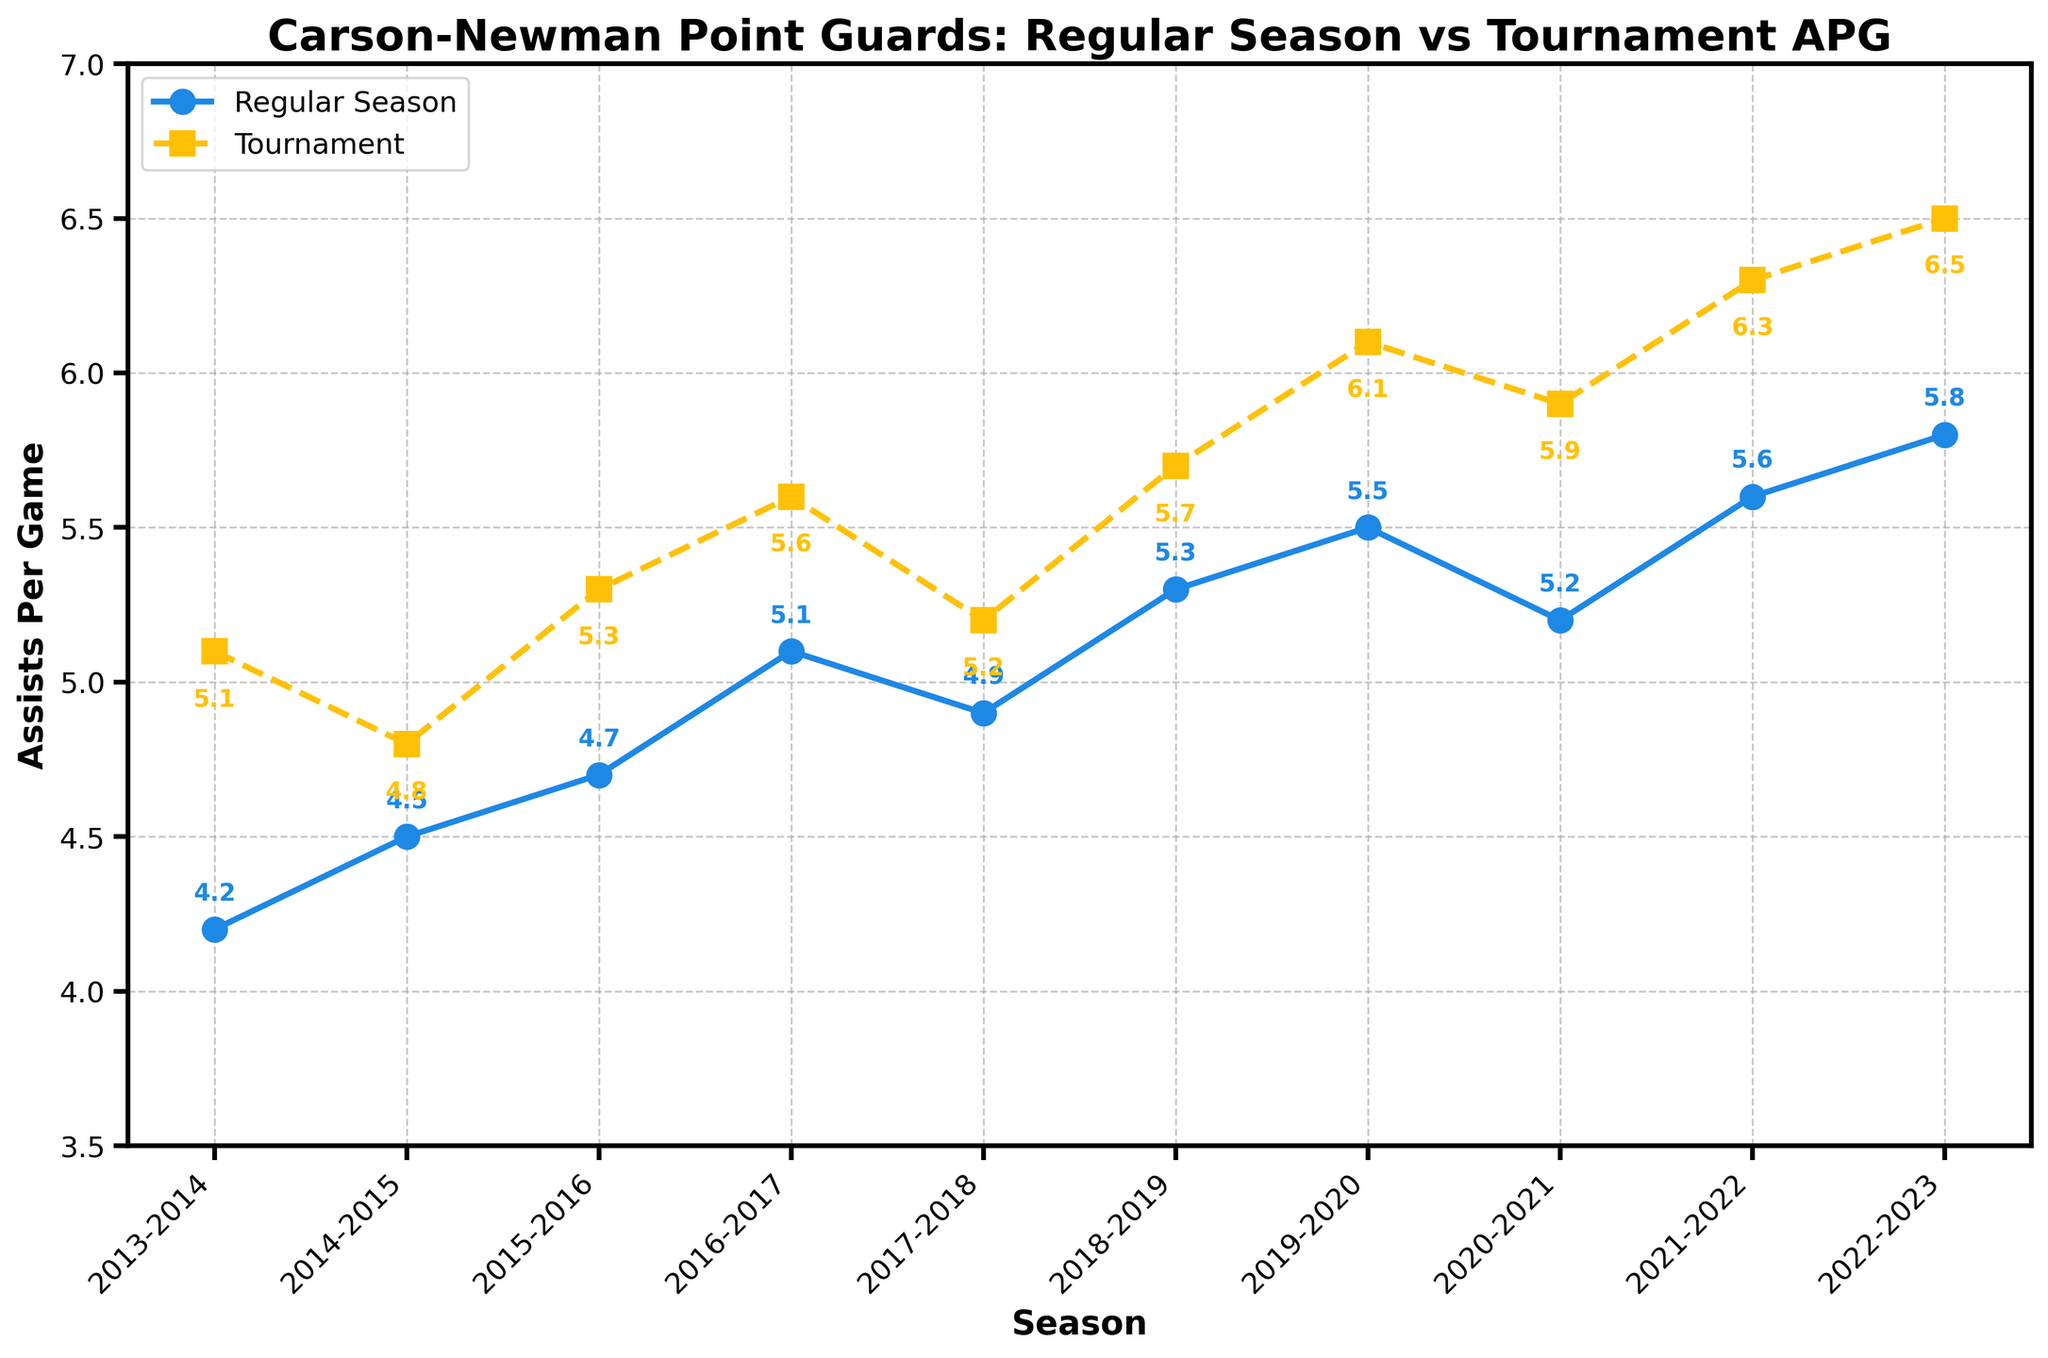Which season had the highest Regular Season APG? The plot shows the Regular Season APG for each season with markers and an annotated value. Identify the highest value among the annotations.
Answer: 2022-2023 How much did the Tournament APG increase from the 2019-2020 season to the 2022-2023 season? Find the Tournament APG for the 2019-2020 season and for the 2022-2023 season, then calculate the difference (6.5 - 6.1).
Answer: 0.4 What is the overall trend in Regular Season APG from 2013-2014 to 2022-2023? Observe the trend line for the Regular Season APG from the start to the end season. The line generally shows an upward trend.
Answer: Increasing Which seasons show a higher Tournament APG than Regular Season APG? Examine the plot and identify seasons where the Tournament APG marker is above the Regular Season APG marker.
Answer: All seasons What was the difference between Regular Season APG and Tournament APG in the 2016-2017 season? Locate both values for the 2016-2017 season on the plot and subtract Regular Season APG from Tournament APG (5.6 - 5.1).
Answer: 0.5 In which season is the difference between Regular Season APG and Tournament APG the smallest? Calculate the difference between Regular Season APG and Tournament APG for each season, then find the smallest difference.
Answer: 2014-2015 What is the average Tournament APG for the seasons 2018-2019 to 2022-2023? Find the Tournament APG for each of the specified seasons, sum them up and divide by the number of seasons ((5.7 + 6.1 + 5.9 + 6.3 + 6.5)/5).
Answer: 6.1 Which season had the biggest increase in Regular Season APG from the previous season? Calculate the year-to-year differences in Regular Season APG and identify the season with the largest increase.
Answer: 2017-2018 to 2018-2019 How did the Regular Season APG change from the 2014-2015 to the 2015-2016 season? Identify the Regular Season APG for these two seasons and calculate the difference (4.7 - 4.5).
Answer: 0.2 